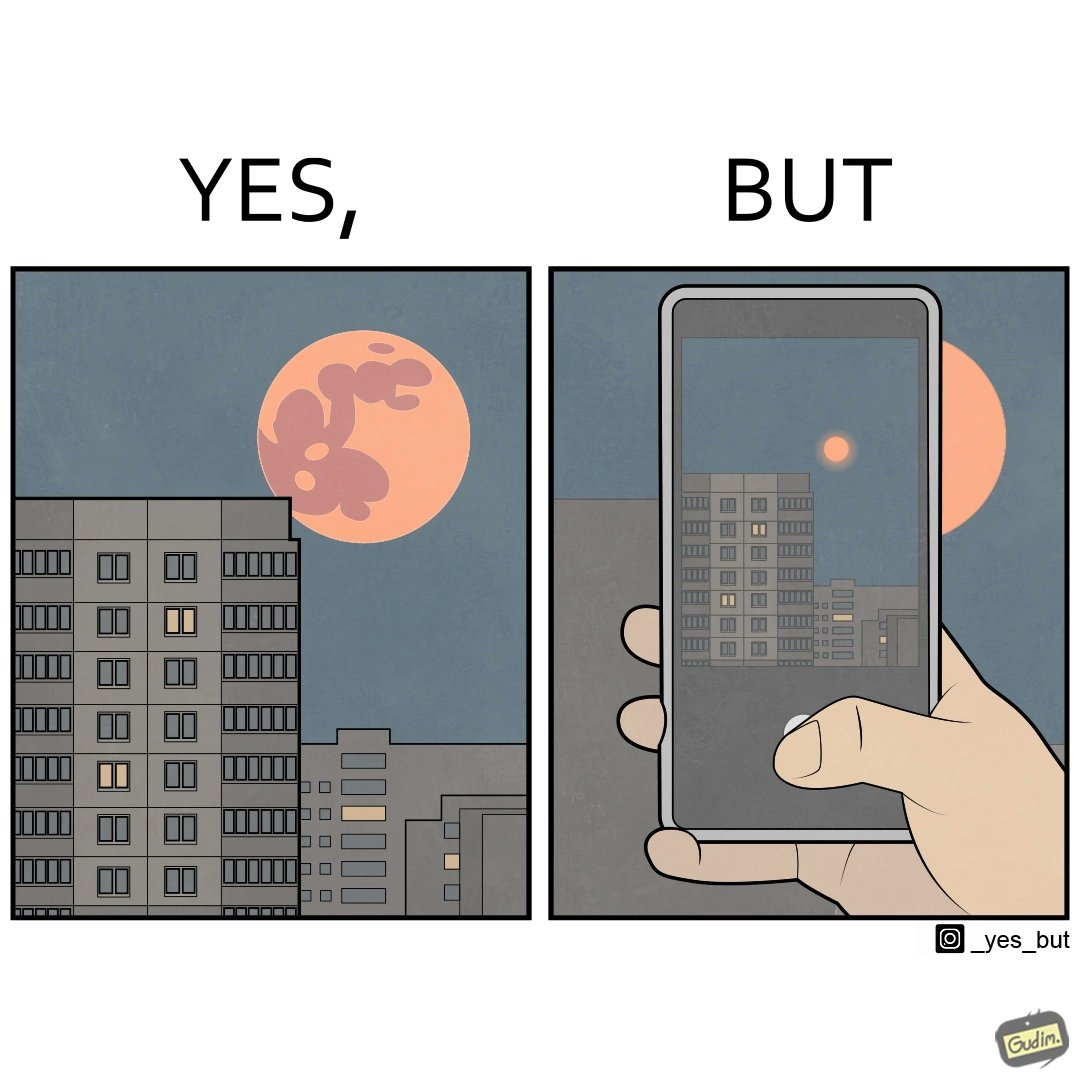Compare the left and right sides of this image. In the left part of the image: a beautiful view of red moon around a building In the right part of the image: a person trying to capture an image of red moon using his phone 